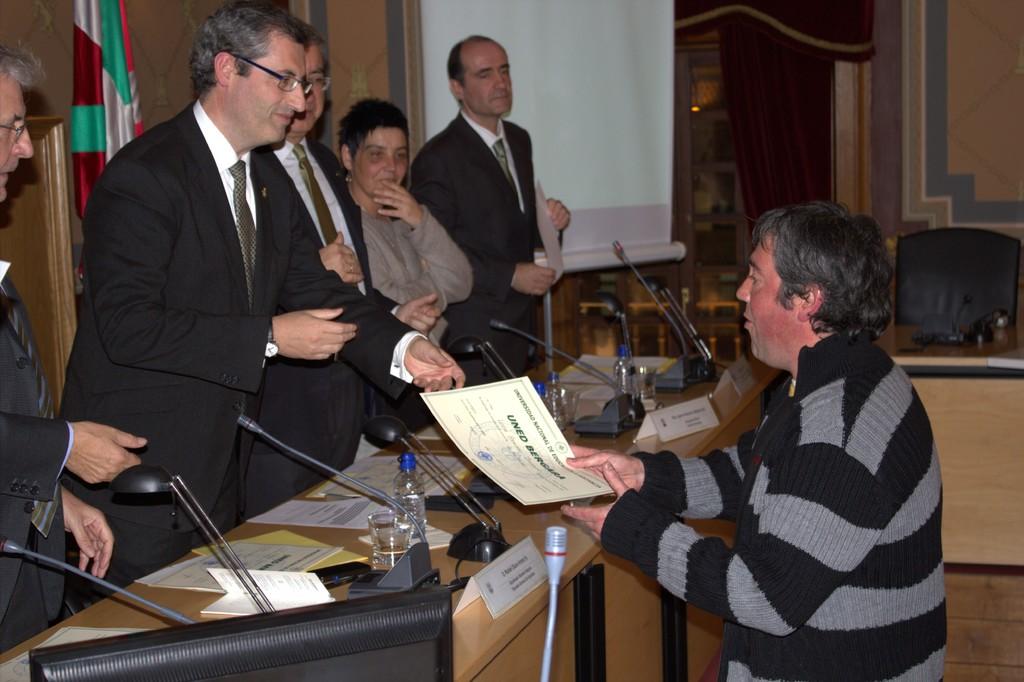What is the first name on the certificate?
Give a very brief answer. Unanswerable. 